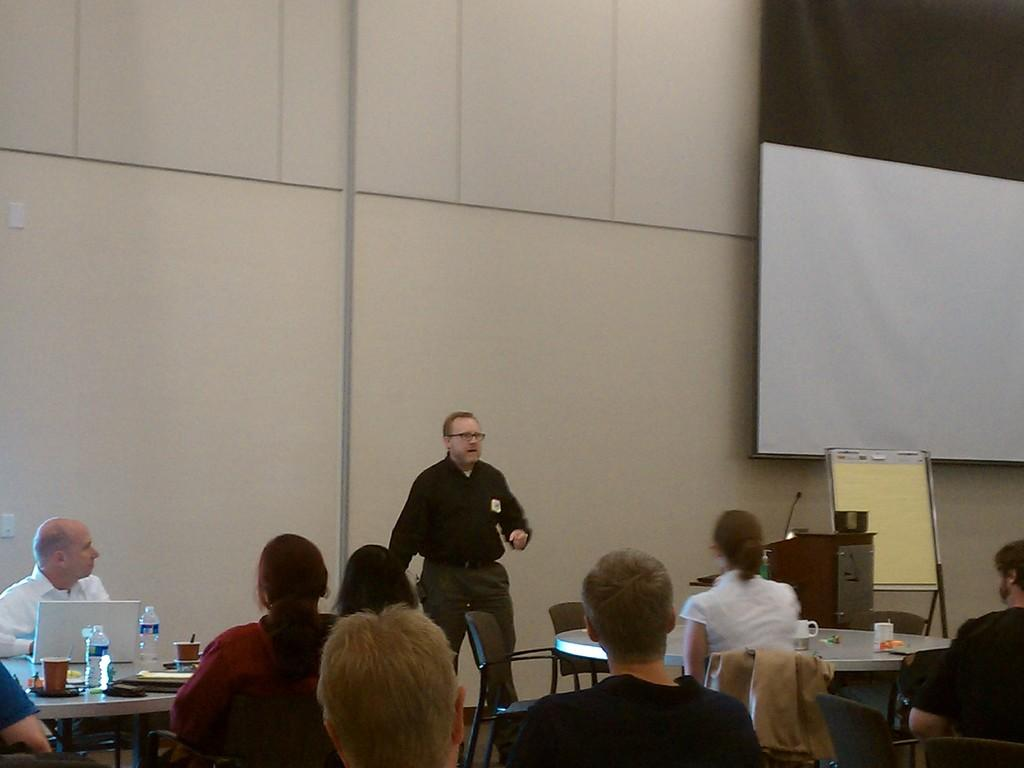What is the main subject of the image? There is a man standing in the middle of the image. What is the man wearing? The man is wearing a black color shirt. What are the other people in the image doing? There are many people sitting in the image, and they are listening to the man. What type of powder can be seen on the man's leg in the image? There is no powder visible on the man's leg in the image. What is the air quality like in the image? The image does not provide any information about the air quality. 